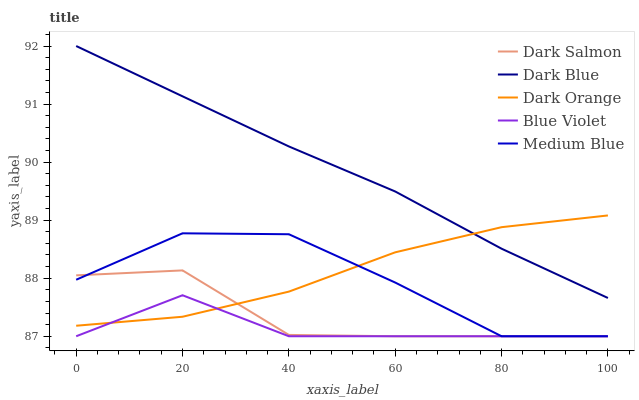Does Blue Violet have the minimum area under the curve?
Answer yes or no. Yes. Does Dark Blue have the maximum area under the curve?
Answer yes or no. Yes. Does Medium Blue have the minimum area under the curve?
Answer yes or no. No. Does Medium Blue have the maximum area under the curve?
Answer yes or no. No. Is Dark Blue the smoothest?
Answer yes or no. Yes. Is Medium Blue the roughest?
Answer yes or no. Yes. Is Dark Salmon the smoothest?
Answer yes or no. No. Is Dark Salmon the roughest?
Answer yes or no. No. Does Medium Blue have the lowest value?
Answer yes or no. Yes. Does Dark Orange have the lowest value?
Answer yes or no. No. Does Dark Blue have the highest value?
Answer yes or no. Yes. Does Medium Blue have the highest value?
Answer yes or no. No. Is Dark Salmon less than Dark Blue?
Answer yes or no. Yes. Is Dark Blue greater than Medium Blue?
Answer yes or no. Yes. Does Blue Violet intersect Medium Blue?
Answer yes or no. Yes. Is Blue Violet less than Medium Blue?
Answer yes or no. No. Is Blue Violet greater than Medium Blue?
Answer yes or no. No. Does Dark Salmon intersect Dark Blue?
Answer yes or no. No. 